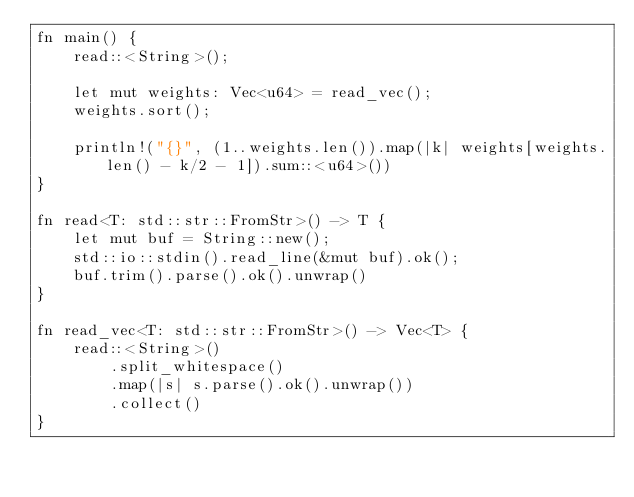Convert code to text. <code><loc_0><loc_0><loc_500><loc_500><_Rust_>fn main() {
    read::<String>();

    let mut weights: Vec<u64> = read_vec();
    weights.sort();

    println!("{}", (1..weights.len()).map(|k| weights[weights.len() - k/2 - 1]).sum::<u64>())
}

fn read<T: std::str::FromStr>() -> T {
    let mut buf = String::new();
    std::io::stdin().read_line(&mut buf).ok();
    buf.trim().parse().ok().unwrap()
}

fn read_vec<T: std::str::FromStr>() -> Vec<T> {
    read::<String>()
        .split_whitespace()
        .map(|s| s.parse().ok().unwrap())
        .collect()
}
</code> 